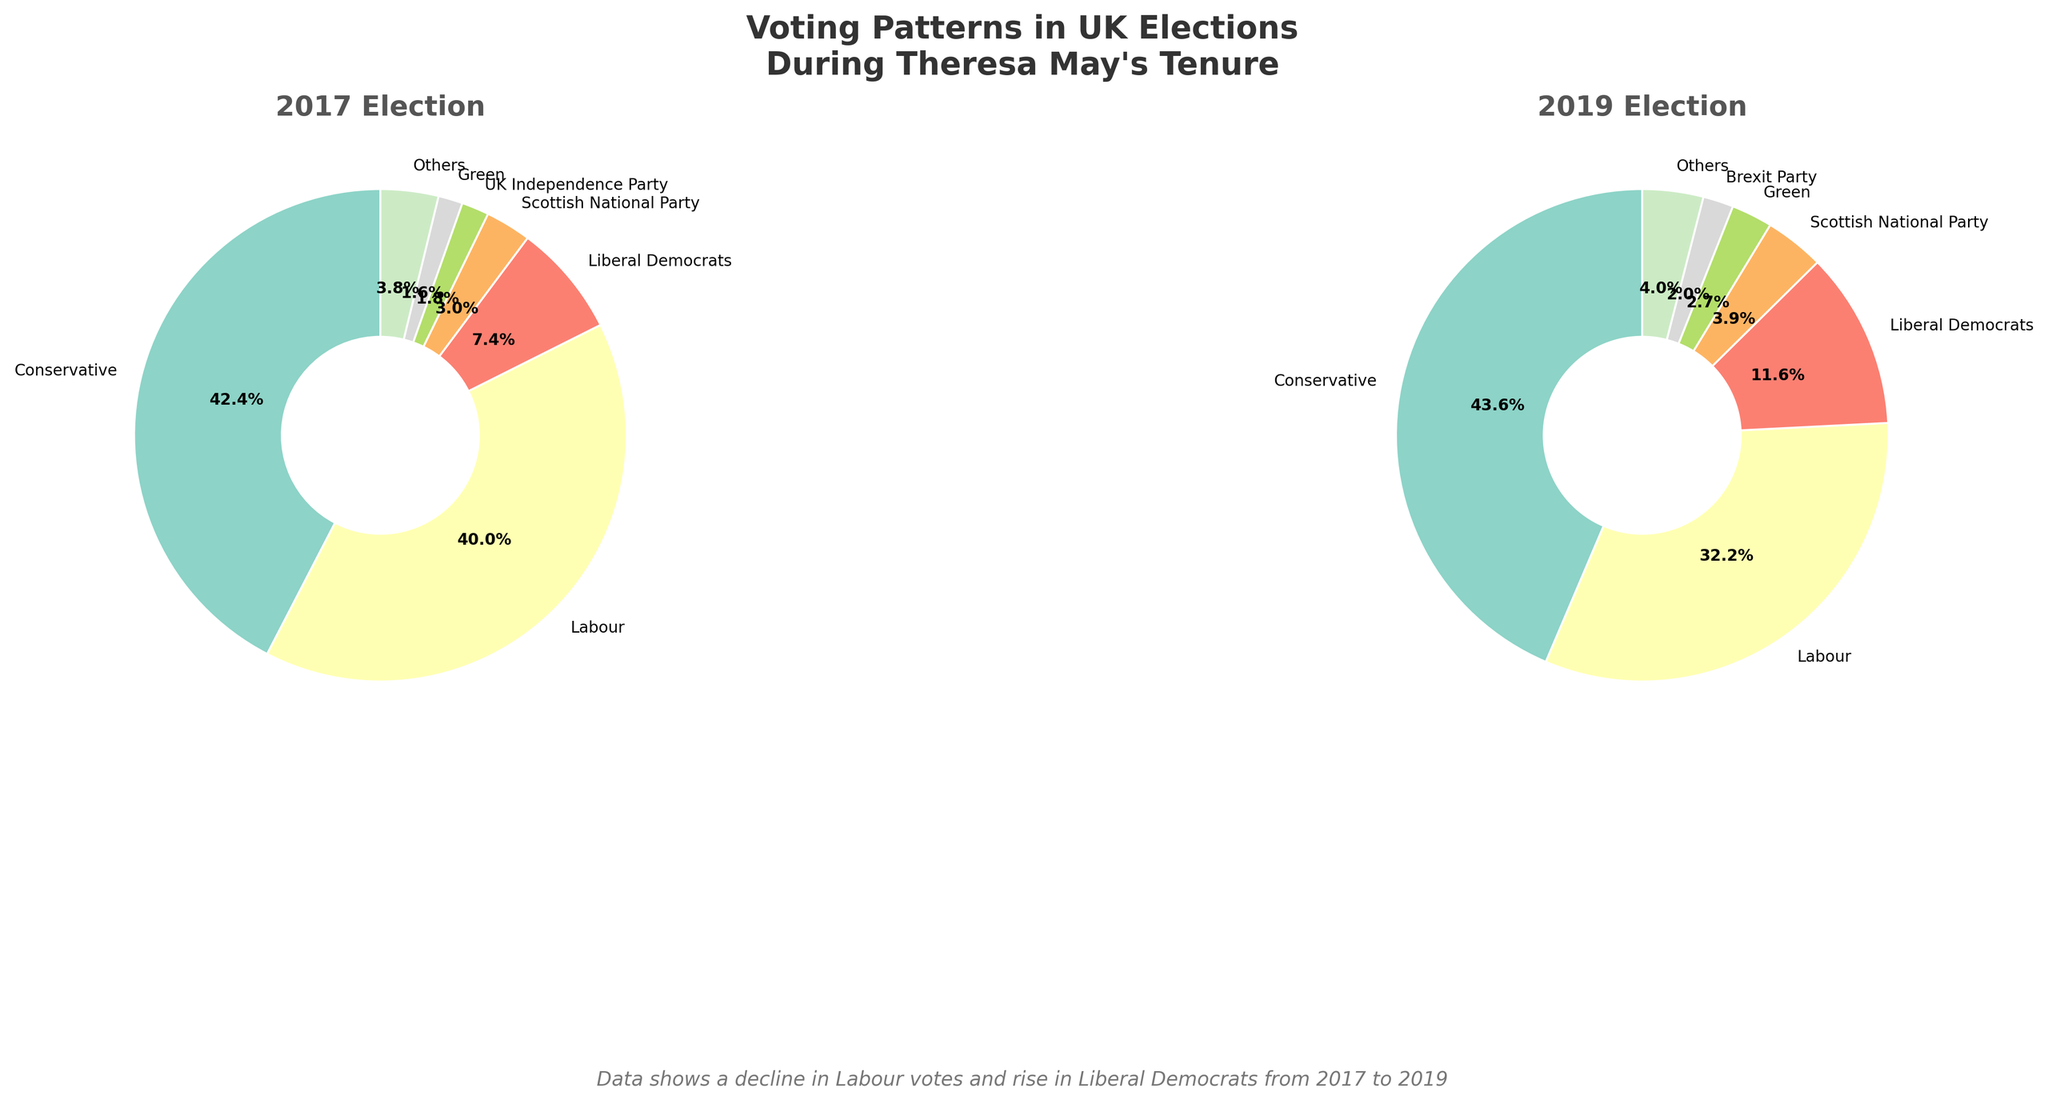What title is presented at the top of the figure? The figure's title is shown at the top and reads, "Voting Patterns in UK Elections During Theresa May's Tenure."
Answer: Voting Patterns in UK Elections During Theresa May's Tenure Which political party had an increase in vote percentage from 2017 to 2019? By looking at both pie charts, observe the percentage labels associated with each party. The Conservative party's share increases from 42.4% in 2017 to 43.6% in 2019.
Answer: Conservative What is the difference in Labour's vote percentage between 2017 and 2019? Identify Labour's percentages in both years, 40.0% in 2017 and 32.2% in 2019. The difference is calculated as 40.0% - 32.2%.
Answer: 7.8% Which year saw a higher vote percentage for the Labour party? Compare the percentages for the Labour party in both pie charts. Labour had 40.0% in 2017 and 32.2% in 2019.
Answer: 2017 How did the vote percentage for the Liberal Democrats change from 2017 to 2019? Examine the percentages for the Liberal Democrats in both years; they had 7.4% in 2017 and 11.6% in 2019. Calculate the change: 11.6% - 7.4%.
Answer: 4.2% In which year did the 'Others' category have a higher percentage of the vote? Compare the 'Others' category percentages: 3.8% in 2017 and 4.0% in 2019.
Answer: 2019 Which minor party (excluding Conservative and Labour) saw the biggest increase in vote percentage from 2017 to 2019? Compare the percentages for minor parties excluding Conservative and Labour. The Liberal Democrats increased from 7.4% to 11.6%, showing the biggest rise.
Answer: Liberal Democrats What can you infer about the performance of the UK Independence Party (UKIP) between 2017 and 2019? Notice that UKIP appears in 2017 with 1.8%, but not in 2019, indicating a significant drop.
Answer: Significant drop How did the vote percentage for the Scottish National Party (SNP) change from 2017 to 2019? Check the SNP percentages: 3.0% in 2017 and 3.9% in 2019. Calculate the change: 3.9% - 3.0%.
Answer: 0.9% Based on the figure, what might be one reason for Labour's poor performance in 2019? Considering Theresa May's tenure, the figure shows a significant drop in Labour's vote from 40.0% in 2017 to 32.2% in 2019, possibly due to the Brexit influence and other political dynamics during that period.
Answer: Brexit influence 